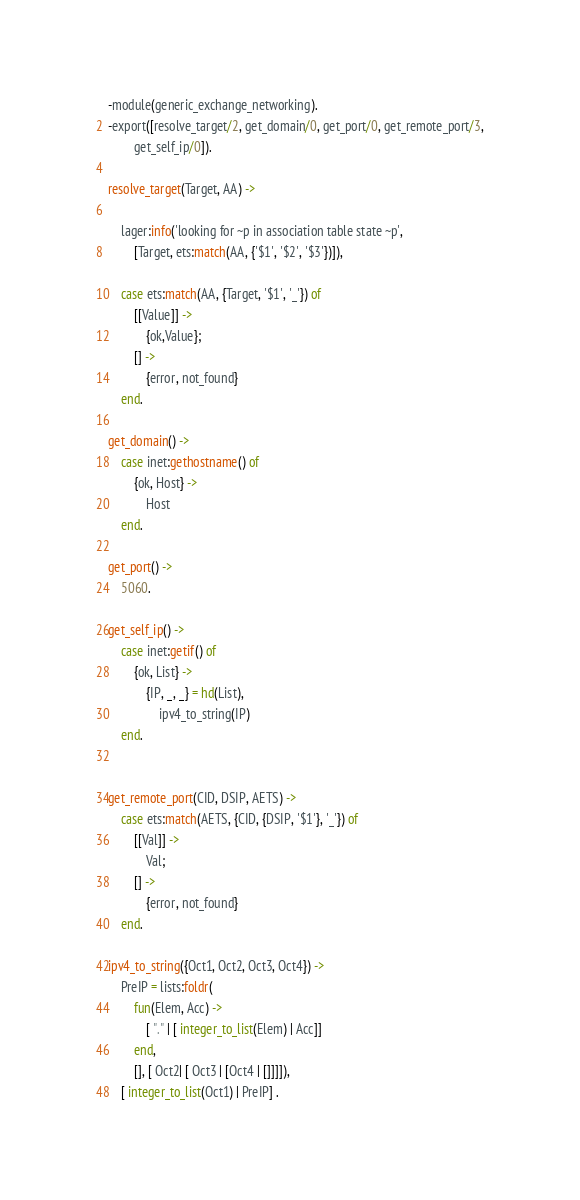Convert code to text. <code><loc_0><loc_0><loc_500><loc_500><_Erlang_>-module(generic_exchange_networking).
-export([resolve_target/2, get_domain/0, get_port/0, get_remote_port/3,
		get_self_ip/0]).

resolve_target(Target, AA) ->

	lager:info('looking for ~p in association table state ~p', 
		[Target, ets:match(AA, {'$1', '$2', '$3'})]),

	case ets:match(AA, {Target, '$1', '_'}) of
		[[Value]] ->
			{ok,Value};
		[] ->
			{error, not_found}
	end.

get_domain() ->
	case inet:gethostname() of
		{ok, Host} ->
			Host
	end.

get_port() ->
	5060.

get_self_ip() ->
	case inet:getif() of
		{ok, List} ->
			{IP, _, _} = hd(List),
				ipv4_to_string(IP)
	end.


get_remote_port(CID, DSIP, AETS) ->
	case ets:match(AETS, {CID, {DSIP, '$1'}, '_'}) of
		[[Val]] ->
			Val;
		[] ->
			{error, not_found}
	end.

ipv4_to_string({Oct1, Oct2, Oct3, Oct4}) ->
	PreIP = lists:foldr( 
		fun(Elem, Acc) ->
			[ "." | [ integer_to_list(Elem) | Acc]]
		end, 
		[], [ Oct2| [ Oct3 | [Oct4 | []]]]),
	[ integer_to_list(Oct1) | PreIP] .
</code> 